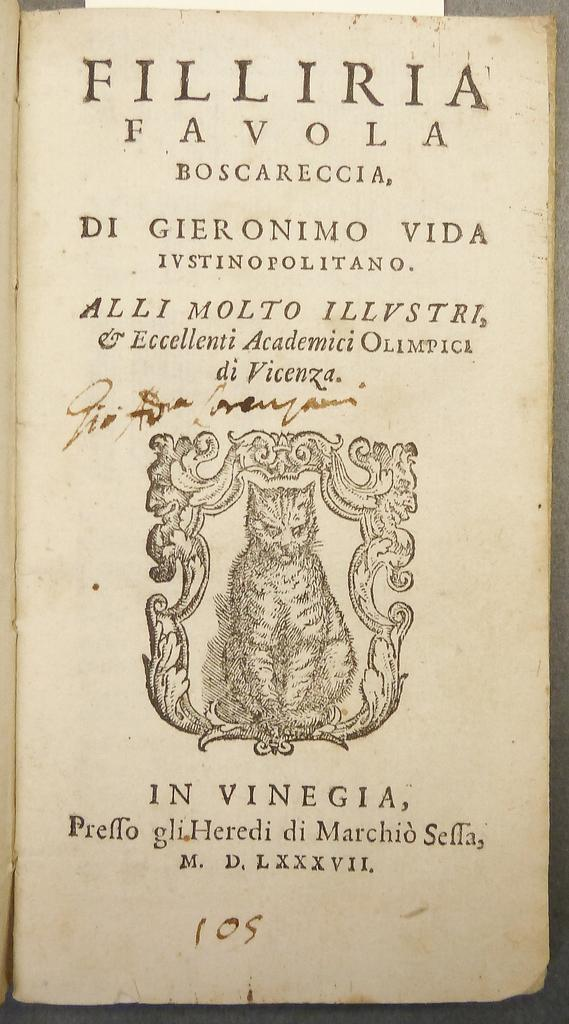Provide a one-sentence caption for the provided image. A book from the past bears the name Filliria Favola on its title page. 